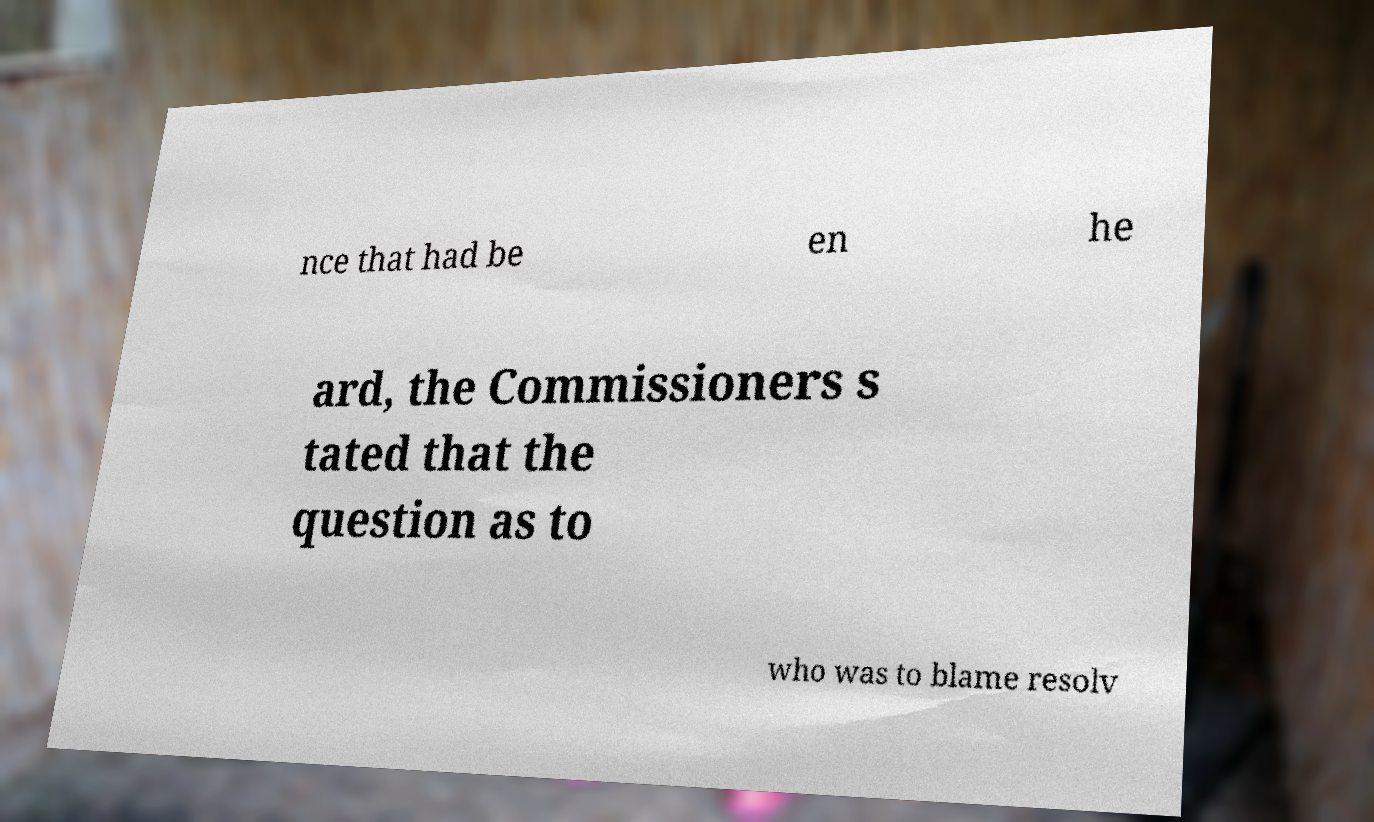I need the written content from this picture converted into text. Can you do that? nce that had be en he ard, the Commissioners s tated that the question as to who was to blame resolv 